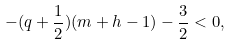<formula> <loc_0><loc_0><loc_500><loc_500>- ( q + \frac { 1 } { 2 } ) ( m + h - 1 ) - \frac { 3 } { 2 } < 0 ,</formula> 